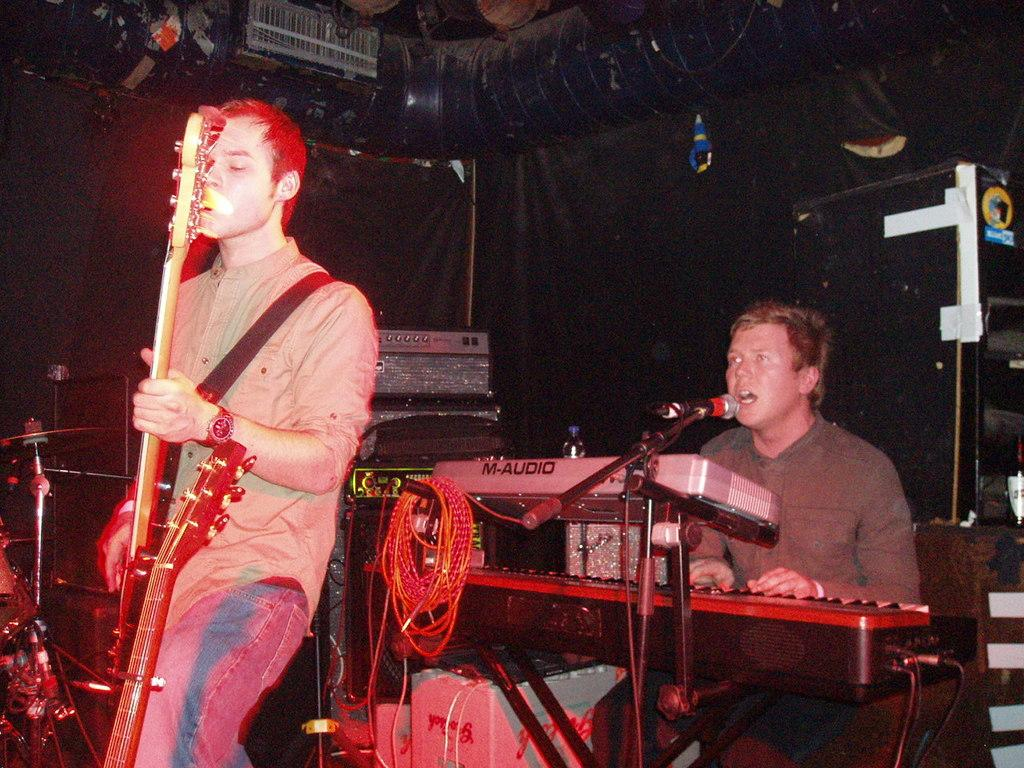What is: What is the man in the image doing? The man is sitting and singing in front of a microphone, and also playing a keyboard. Is there anyone else in the image? Yes, there is another man standing and playing a guitar. What type of food is being used as glue in the image? There is no food or glue present in the image; it features two men playing musical instruments. 